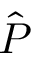<formula> <loc_0><loc_0><loc_500><loc_500>\hat { P }</formula> 